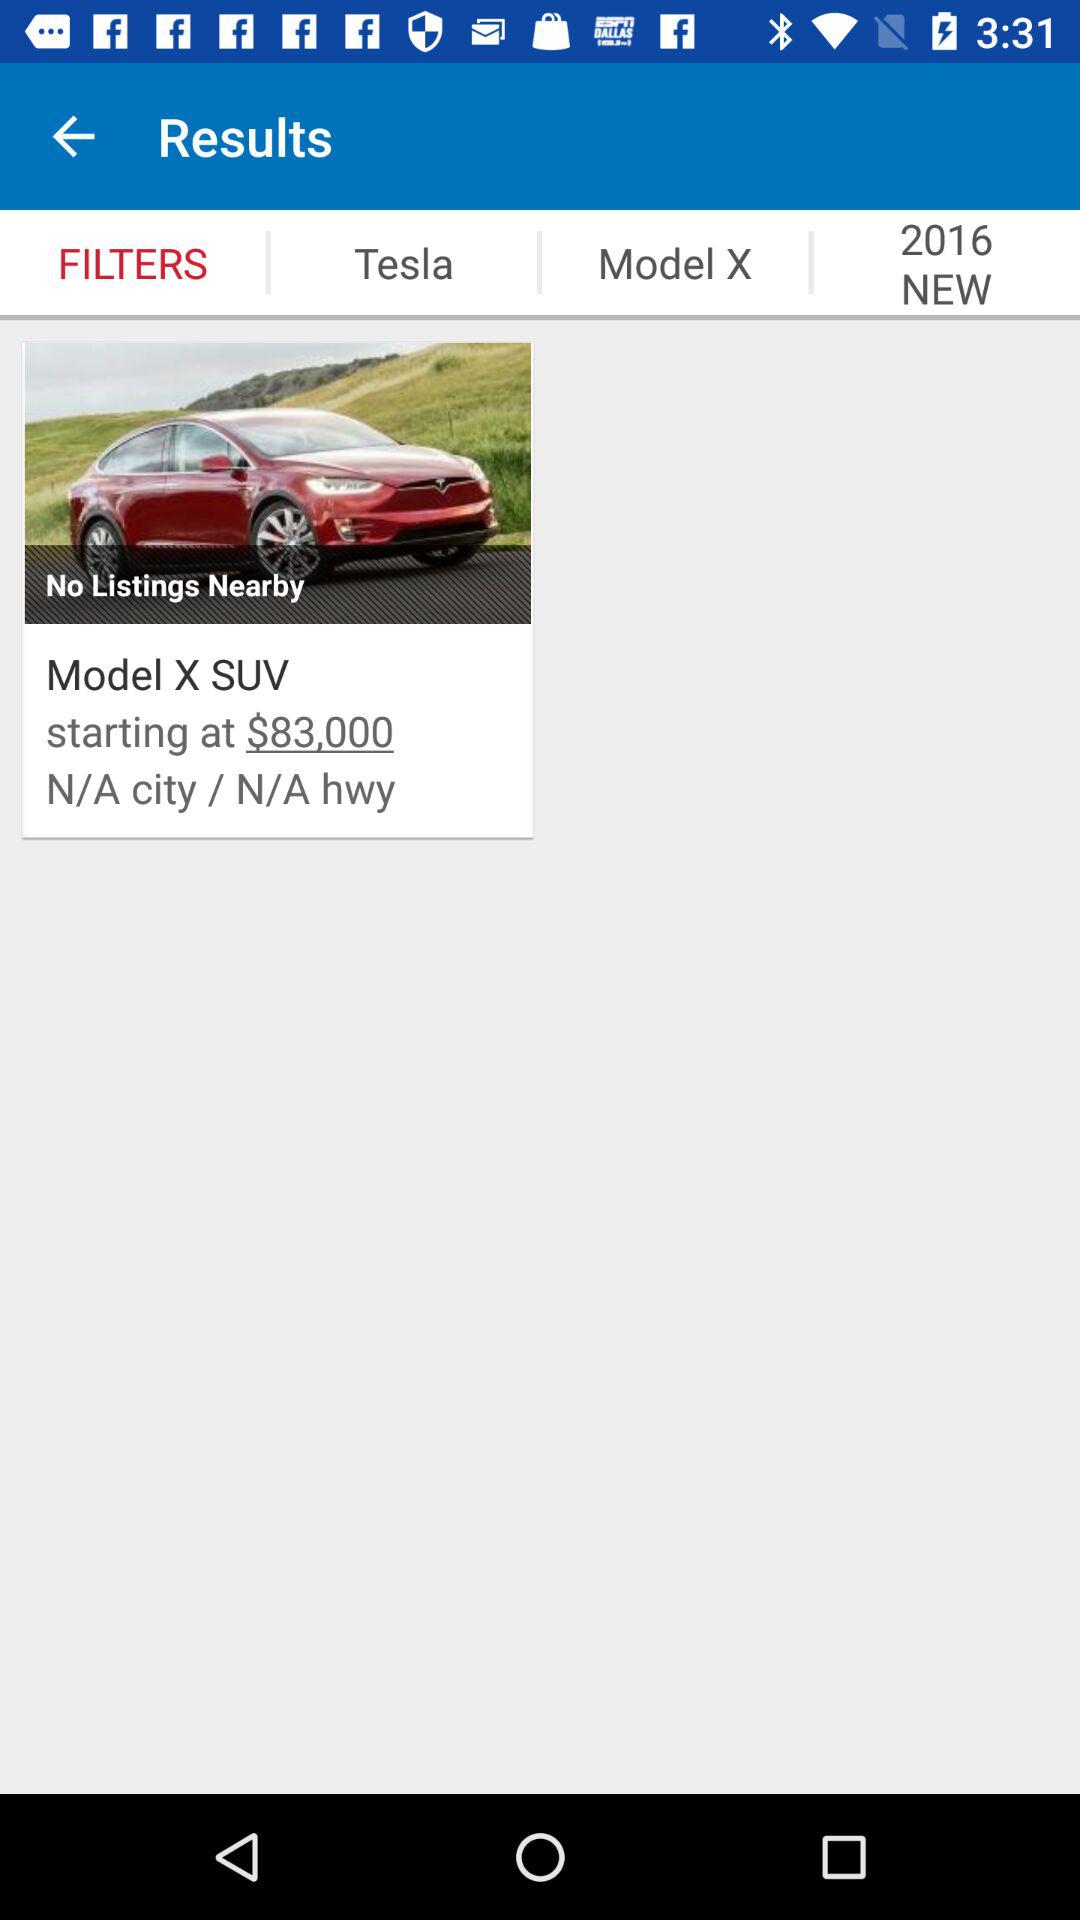What is the year? The year is 2016. 